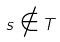Convert formula to latex. <formula><loc_0><loc_0><loc_500><loc_500>s \notin T</formula> 